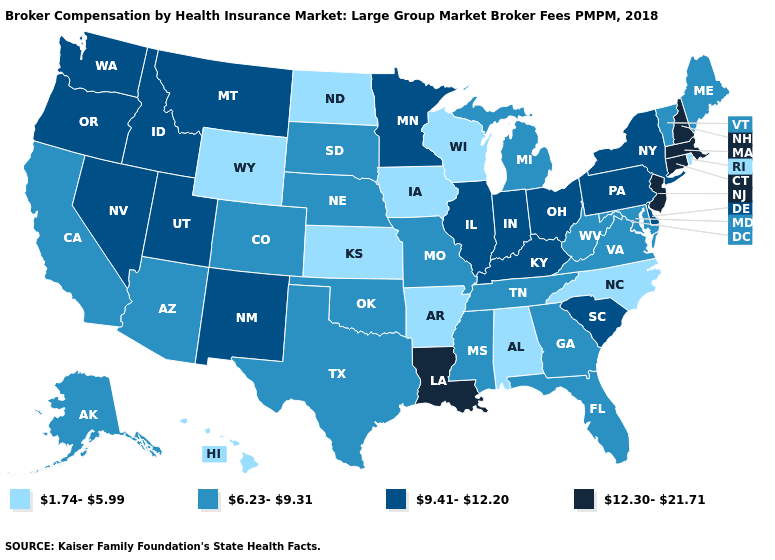Name the states that have a value in the range 9.41-12.20?
Be succinct. Delaware, Idaho, Illinois, Indiana, Kentucky, Minnesota, Montana, Nevada, New Mexico, New York, Ohio, Oregon, Pennsylvania, South Carolina, Utah, Washington. What is the value of Arkansas?
Short answer required. 1.74-5.99. What is the value of Florida?
Give a very brief answer. 6.23-9.31. What is the lowest value in the USA?
Answer briefly. 1.74-5.99. Among the states that border Kentucky , does Illinois have the lowest value?
Be succinct. No. Which states have the lowest value in the Northeast?
Quick response, please. Rhode Island. Which states have the lowest value in the USA?
Keep it brief. Alabama, Arkansas, Hawaii, Iowa, Kansas, North Carolina, North Dakota, Rhode Island, Wisconsin, Wyoming. Name the states that have a value in the range 12.30-21.71?
Give a very brief answer. Connecticut, Louisiana, Massachusetts, New Hampshire, New Jersey. Does the map have missing data?
Write a very short answer. No. Does Tennessee have a higher value than Rhode Island?
Write a very short answer. Yes. What is the value of North Carolina?
Give a very brief answer. 1.74-5.99. Name the states that have a value in the range 1.74-5.99?
Give a very brief answer. Alabama, Arkansas, Hawaii, Iowa, Kansas, North Carolina, North Dakota, Rhode Island, Wisconsin, Wyoming. What is the value of New Mexico?
Answer briefly. 9.41-12.20. What is the value of Florida?
Concise answer only. 6.23-9.31. What is the lowest value in the MidWest?
Be succinct. 1.74-5.99. 